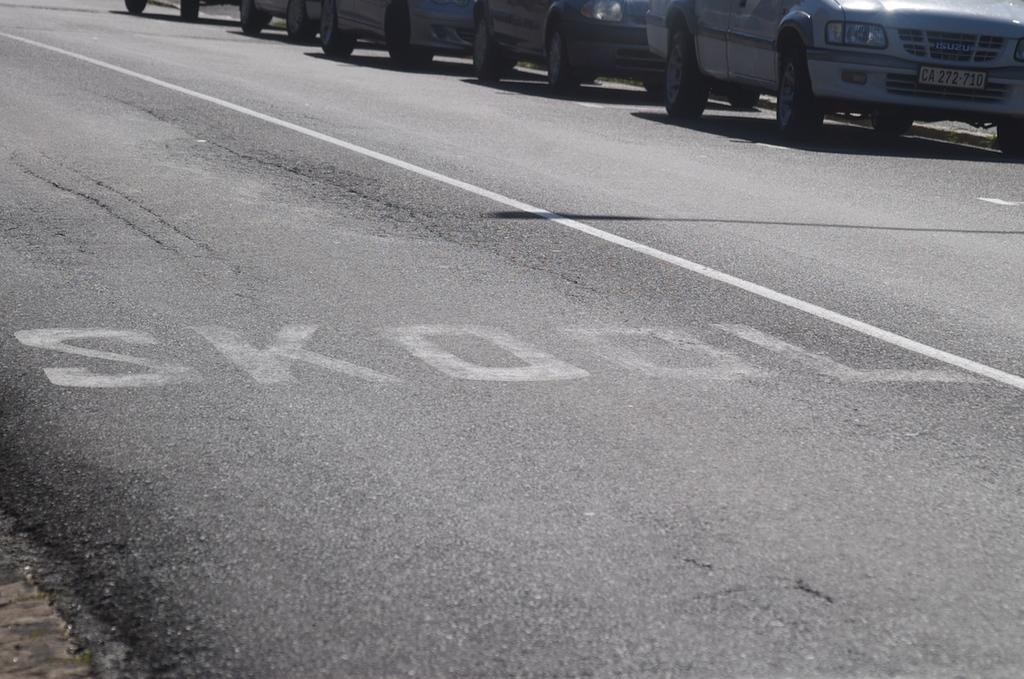What can be seen on the road in the image? There are vehicles on the road in the image. How many horses are visible in the image? There are no horses present in the image; it features vehicles on the road. What type of tree can be seen near the vehicles in the image? There is no tree present in the image; it only shows vehicles on the road. 